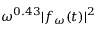<formula> <loc_0><loc_0><loc_500><loc_500>\omega ^ { 0 . 4 3 } | f _ { \omega } ( t ) | ^ { 2 }</formula> 